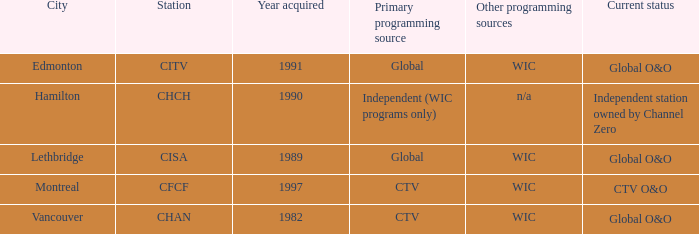For citv, what is the least amount needed? 1991.0. 